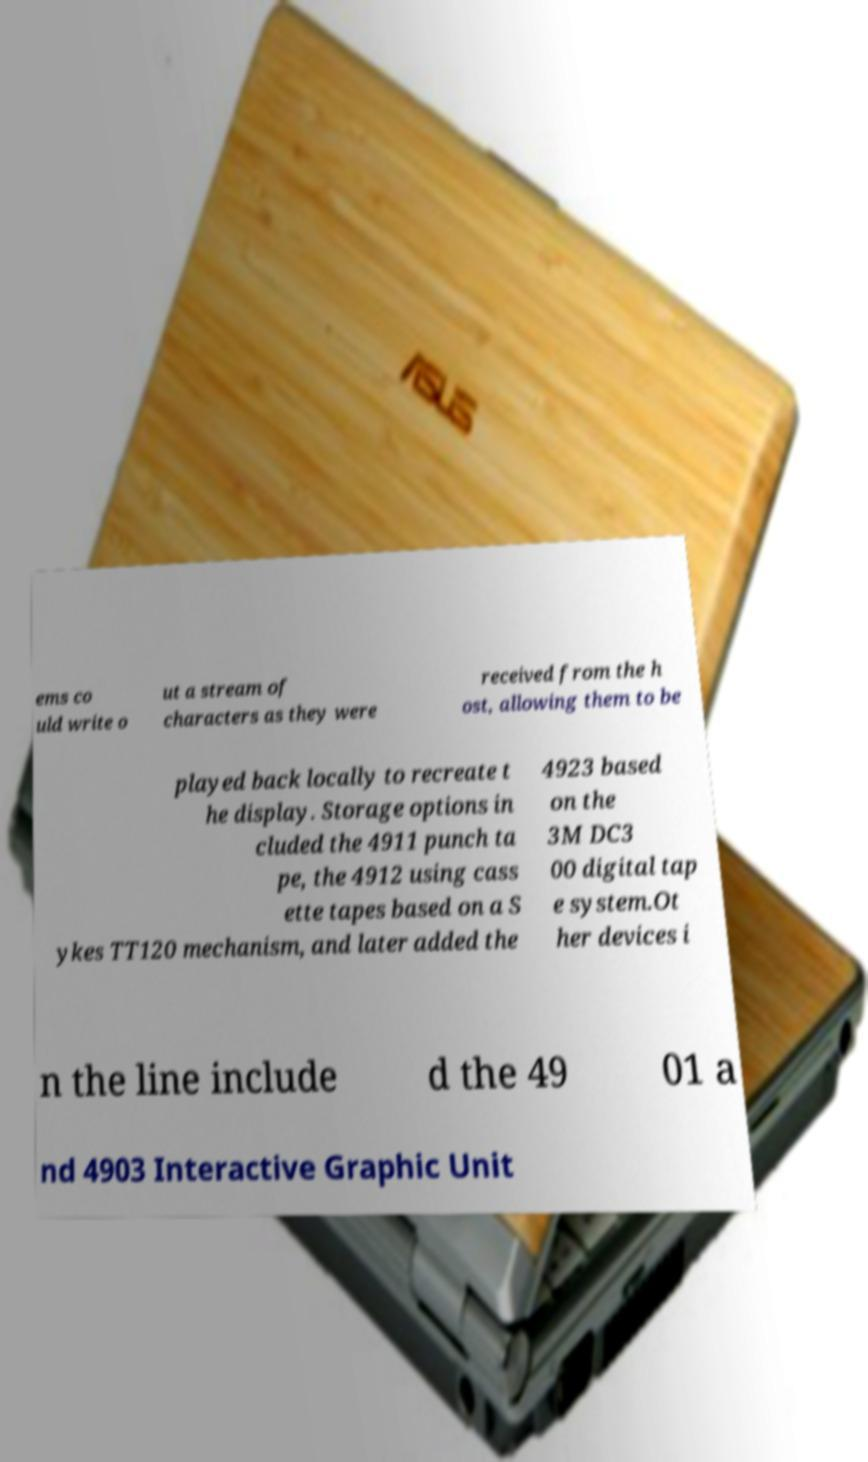There's text embedded in this image that I need extracted. Can you transcribe it verbatim? ems co uld write o ut a stream of characters as they were received from the h ost, allowing them to be played back locally to recreate t he display. Storage options in cluded the 4911 punch ta pe, the 4912 using cass ette tapes based on a S ykes TT120 mechanism, and later added the 4923 based on the 3M DC3 00 digital tap e system.Ot her devices i n the line include d the 49 01 a nd 4903 Interactive Graphic Unit 